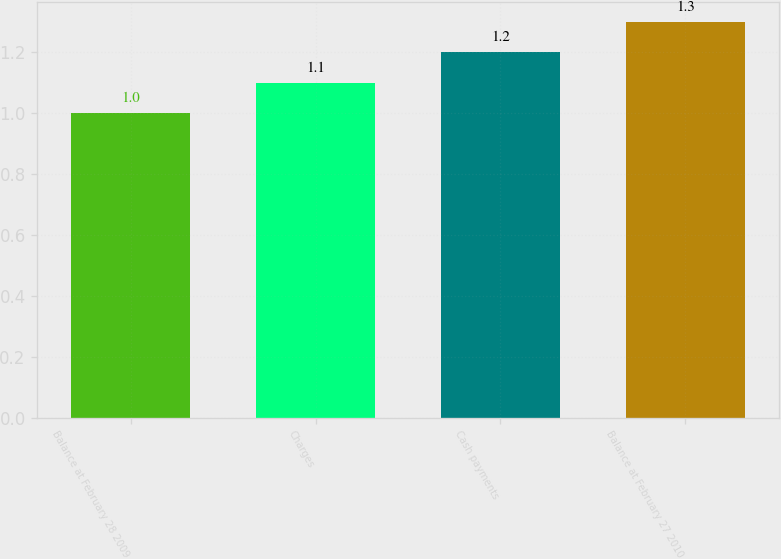<chart> <loc_0><loc_0><loc_500><loc_500><bar_chart><fcel>Balance at February 28 2009<fcel>Charges<fcel>Cash payments<fcel>Balance at February 27 2010<nl><fcel>1<fcel>1.1<fcel>1.2<fcel>1.3<nl></chart> 